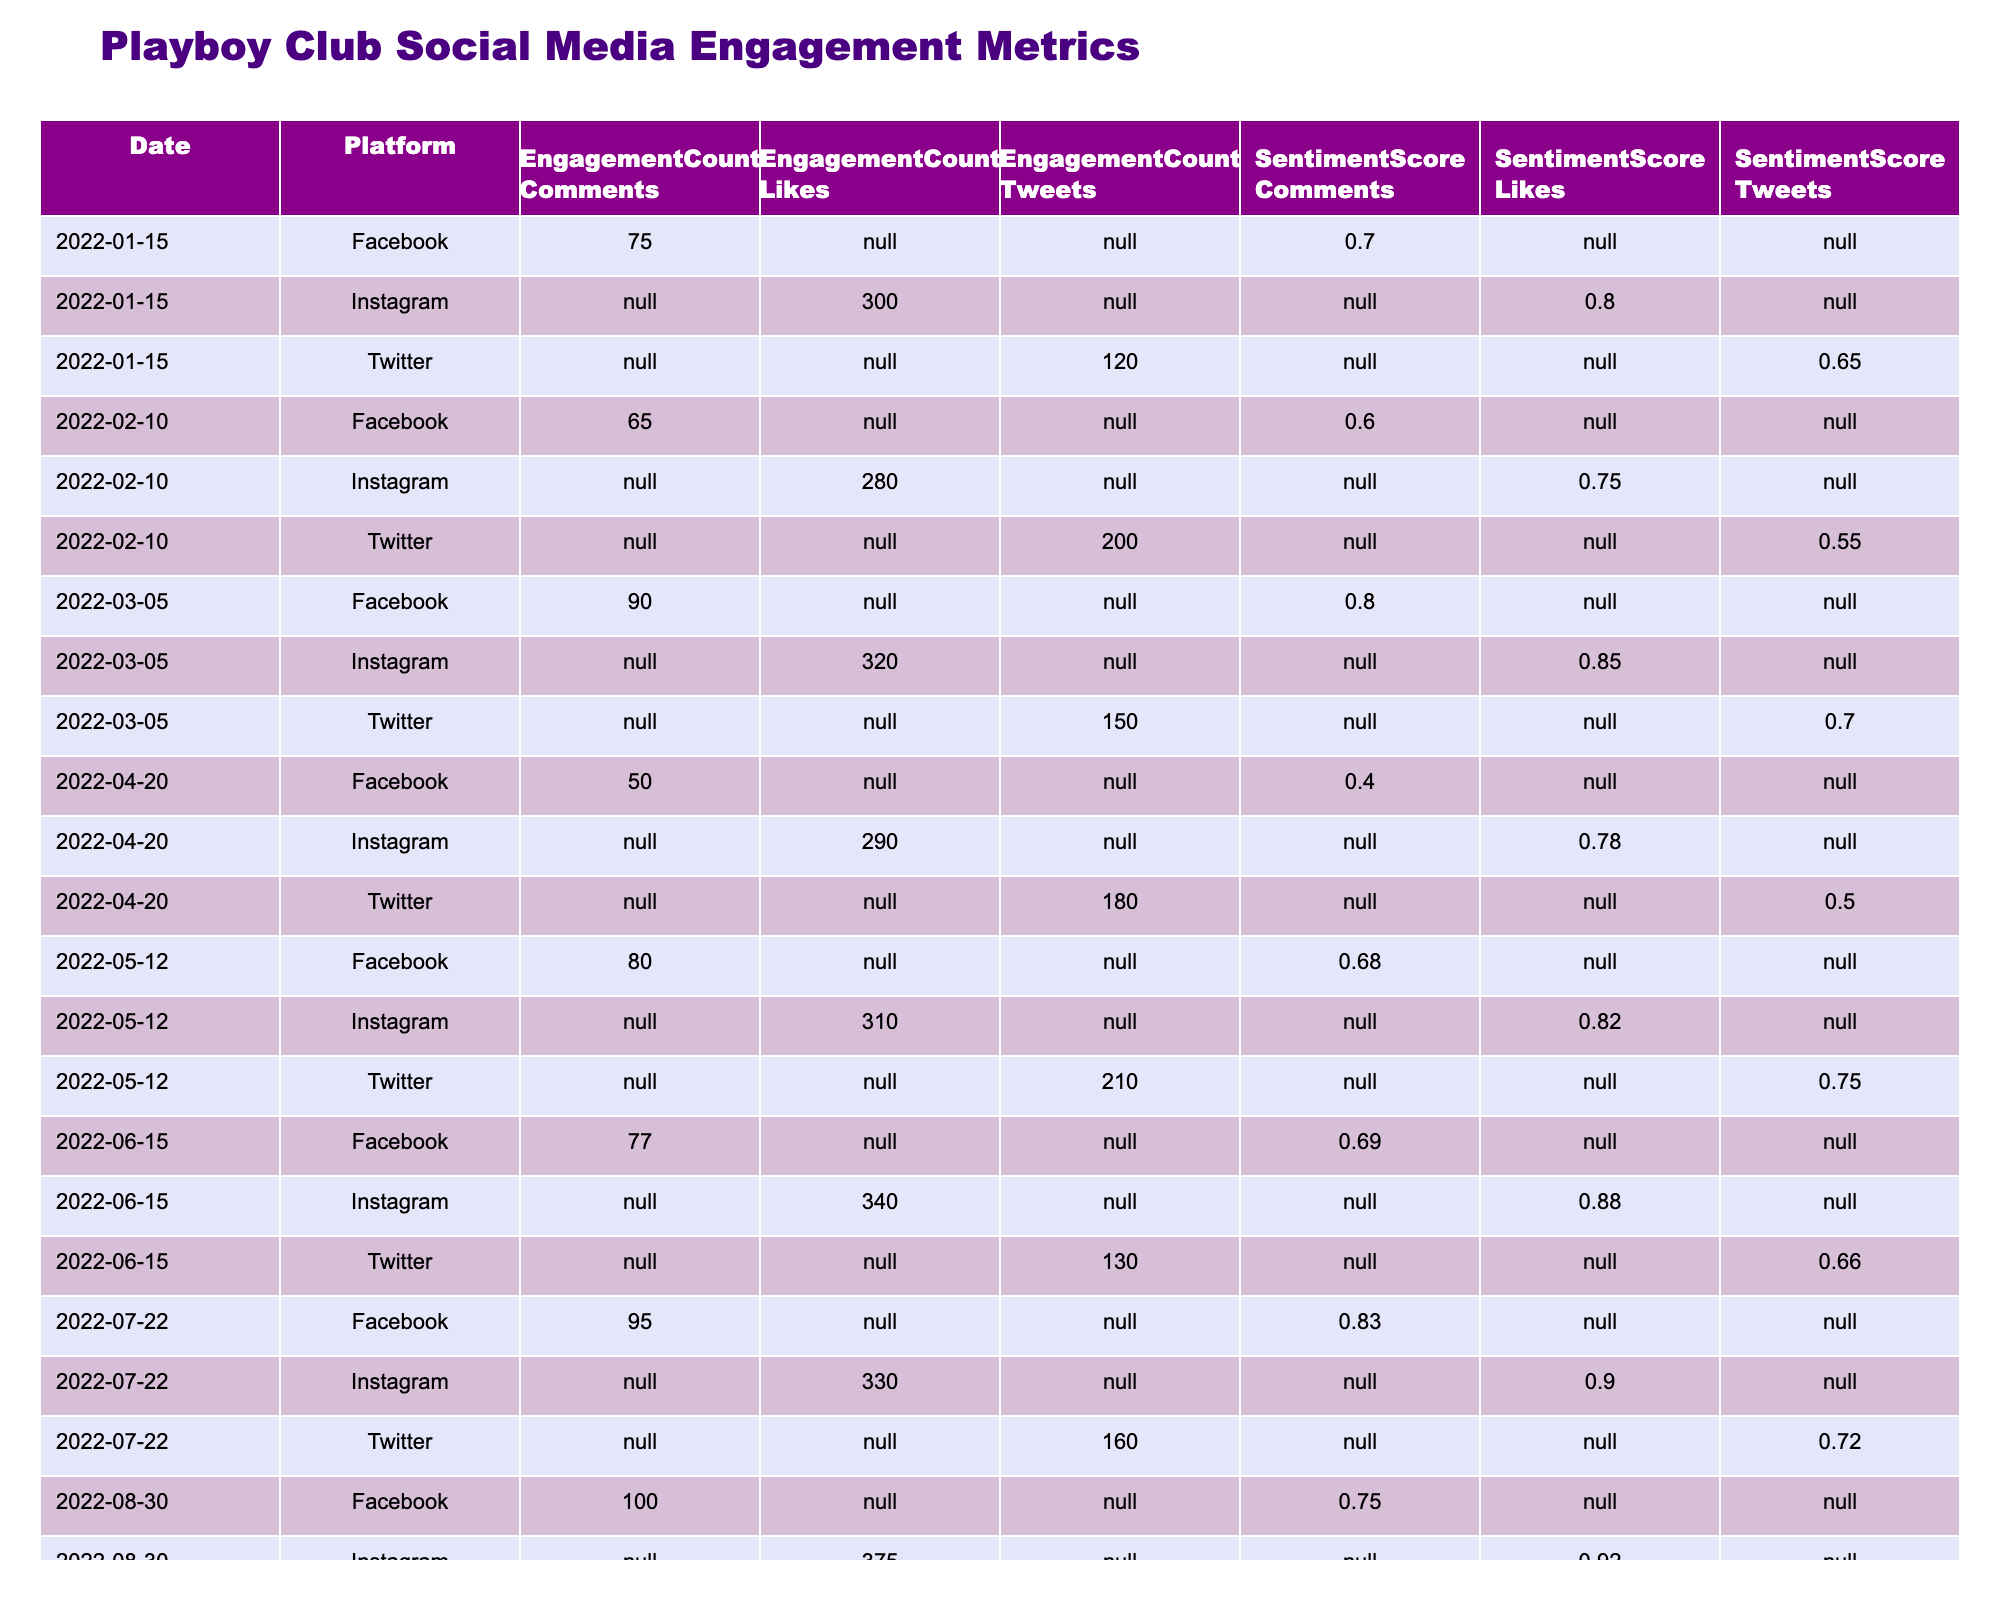What was the total Twitter engagement count for January 2022? In January 2022, there is only one entry for Twitter with an engagement count of 120. Thus, the total for that month is simply 120.
Answer: 120 What was the sentiment score for Instagram likes in March 2022? For Instagram in March 2022, the sentiment score listed is 0.85, indicating the level of positive engagement from users.
Answer: 0.85 On which date did Facebook have the lowest engagement count for comments? Upon reviewing the Facebook comments across all dates, April 20, 2022, has the lowest engagement count of 50, making it the date with the least interaction.
Answer: April 20, 2022 In April 2022, what was the difference in engagement count between Twitter and Instagram? For April 2022, Twitter had an engagement count of 180, while Instagram reported 290. The difference is calculated as 290 - 180 = 110.
Answer: 110 Which platform had the highest engagement count for likes in August 2022? In August 2022, Instagram had the highest engagement count for likes with a total of 375, compared to Twitter and Facebook.
Answer: Instagram What was the average sentiment score for Twitter across all months? The sentiment scores for Twitter are as follows: 0.65, 0.55, 0.70, 0.50, 0.75, 0.66, 0.72, and 0.77. Summing these gives a total of 5.65. Dividing that by the number of entries (8) yields an average of 5.65 / 8 = 0.70625, rounding to 0.71 for simplicity.
Answer: 0.71 During which month did the engagement count for Facebook comments witness the largest decrease compared to the previous month? By examining the monthly engagement counts, we see that from February to March, Facebook dropped from 65 to 90, an increase; from March to April, it falls from 90 to 50, which is a notable decrease of 40. The largest drop thus occurred from March to April.
Answer: March to April Was there an increase or decrease in Instagram likes from June to July 2022? In June 2022, Instagram had 340 likes, while in July, it went down to 330. This indicates a decrease of 10 likes from June to July.
Answer: Decrease What was the engagement count trend for Twitter over the first half of 2022? Analyzing the monthly engagement counts for Twitter: 120 (January), 200 (February), 150 (March), 180 (April), 210 (May), and 130 (June), we see an increase from January to February, followed by fluctuations until June. The overall trend shows inconsistency throughout the first half.
Answer: Fluctuating Which social media platform had the overall highest engagement count in February 2022? In February, Twitter had 200, Facebook had 65, and Instagram had 280. Comparing these, Instagram has the highest engagement count of 280 that month.
Answer: Instagram 